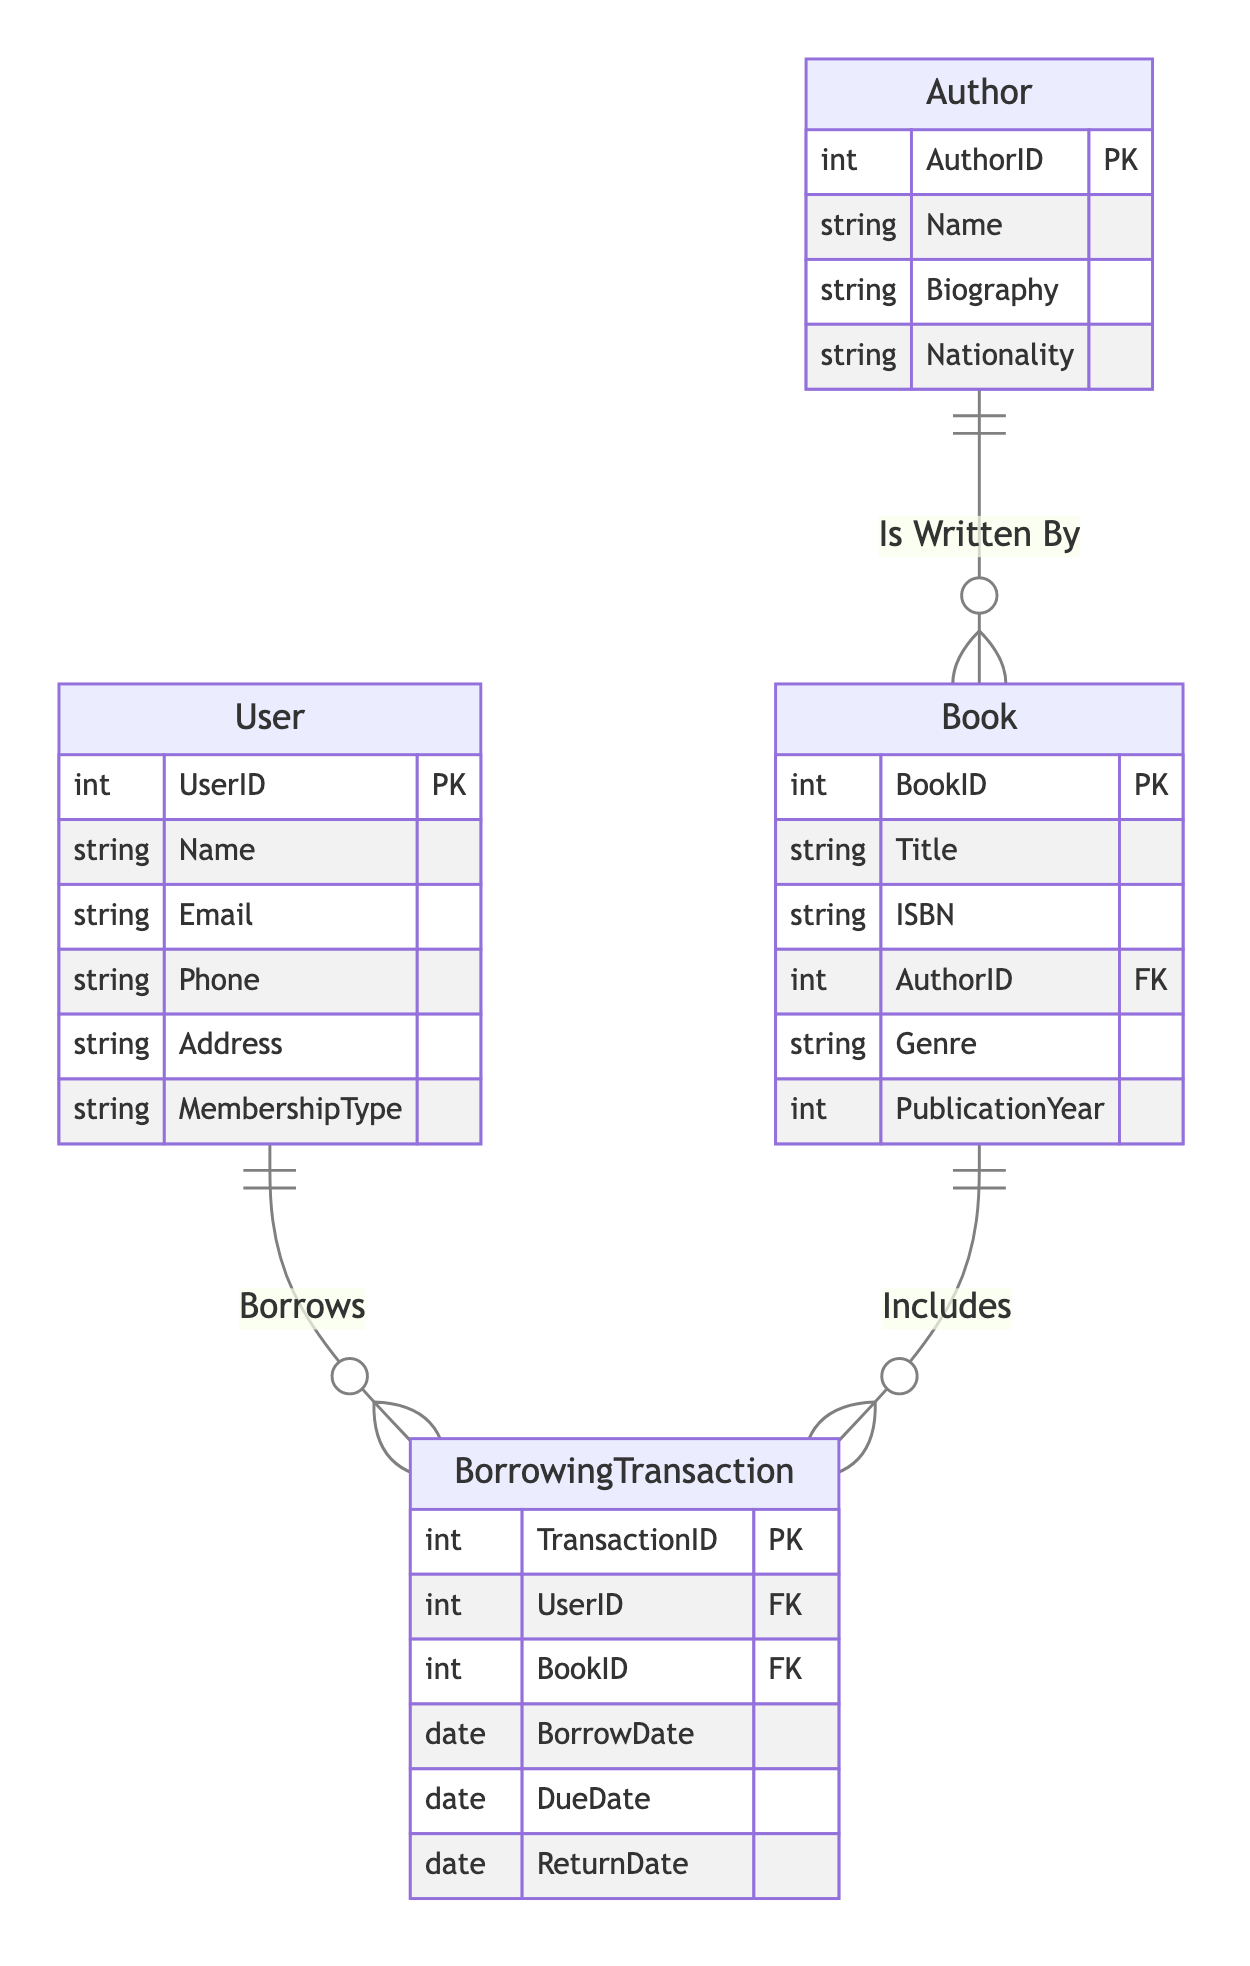What is the primary key of the User entity? The primary key is specified in the User entity section of the diagram as "UserID".
Answer: UserID How many attributes does the Author entity have? The Author entity lists four attributes: AuthorID, Name, Biography, and Nationality, thus totaling four.
Answer: 4 What relationship connects User and BorrowingTransaction entities? The relationship that connects User and BorrowingTransaction is named "Borrows".
Answer: Borrows How many authors can a book be associated with? According to the "IsWrittenBy" relationship in the diagram, each book can be associated with many authors, implying one author can write multiple books. Thus, it reflects a many-to-one relationship.
Answer: Many What is the foreign key in the Book entity? In the Book entity, the foreign key is specified as "AuthorID".
Answer: AuthorID What is the maximum number of borrowing transactions a user can have? The relationship "Borrows" indicates a one-to-many relationship, indicating that one user can have multiple borrowing transactions. Thus, theoretically, there is no specific limit defined in this scenario.
Answer: Many What is the relationship type between BorrowingTransaction and Book? The relationship type between BorrowingTransaction and Book is "many to one", indicating several borrowing transactions may include the same book.
Answer: Many to one What information does the BorrowingTransaction include about the book borrowed? The BorrowingTransaction includes the BookID, which acts as the foreign key connecting to the Book entity, thereby identifying the borrowed book.
Answer: BookID How many primary keys exist in the diagram? By counting the primary keys across all entities, we find four: UserID for User, AuthorID for Author, BookID for Book, and TransactionID for BorrowingTransaction, leading to a total of four primary keys.
Answer: 4 